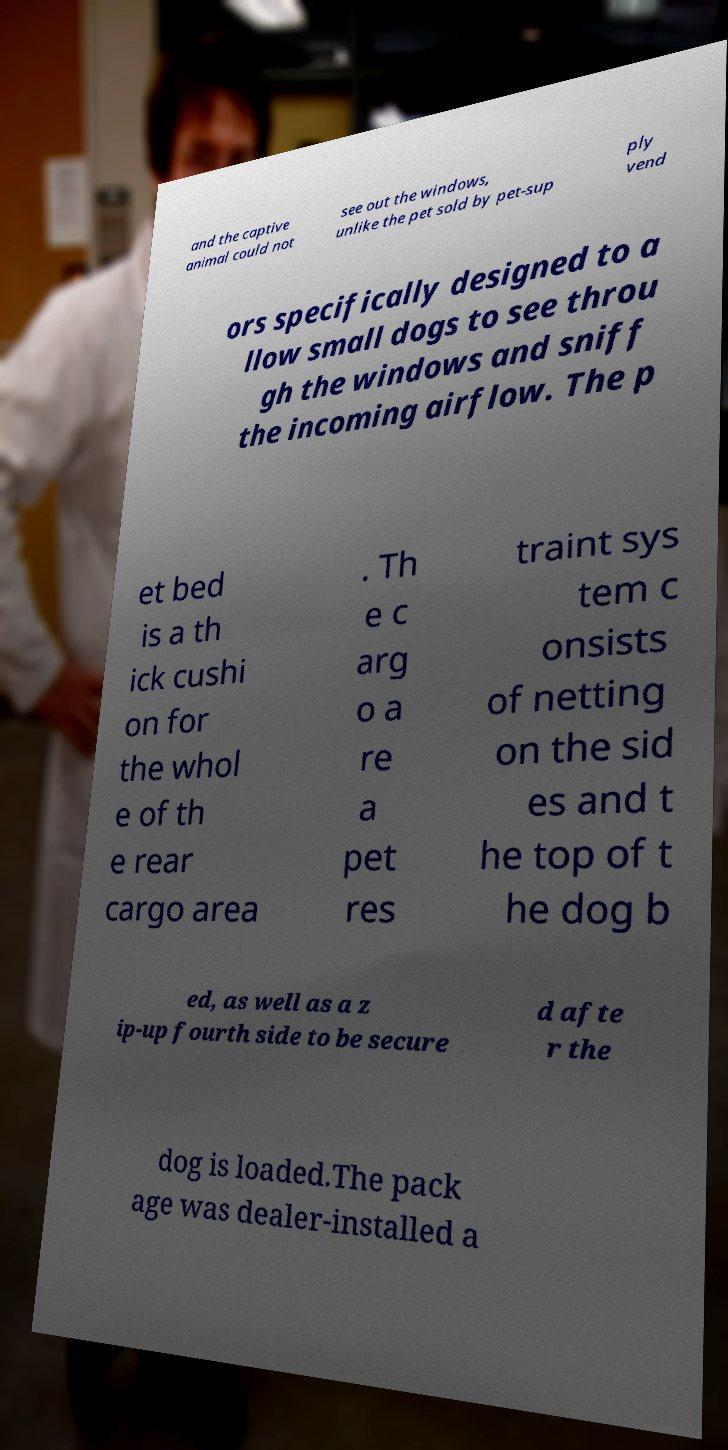Please read and relay the text visible in this image. What does it say? and the captive animal could not see out the windows, unlike the pet sold by pet-sup ply vend ors specifically designed to a llow small dogs to see throu gh the windows and sniff the incoming airflow. The p et bed is a th ick cushi on for the whol e of th e rear cargo area . Th e c arg o a re a pet res traint sys tem c onsists of netting on the sid es and t he top of t he dog b ed, as well as a z ip-up fourth side to be secure d afte r the dog is loaded.The pack age was dealer-installed a 